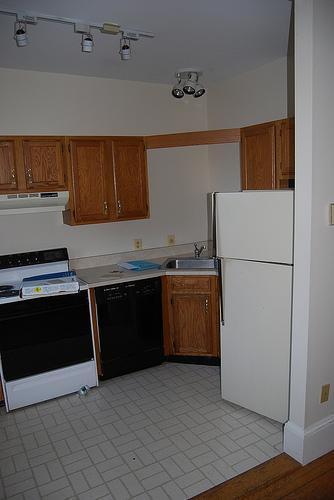How many cabinets are shown?
Give a very brief answer. 7. How many lights are shown?
Give a very brief answer. 6. 